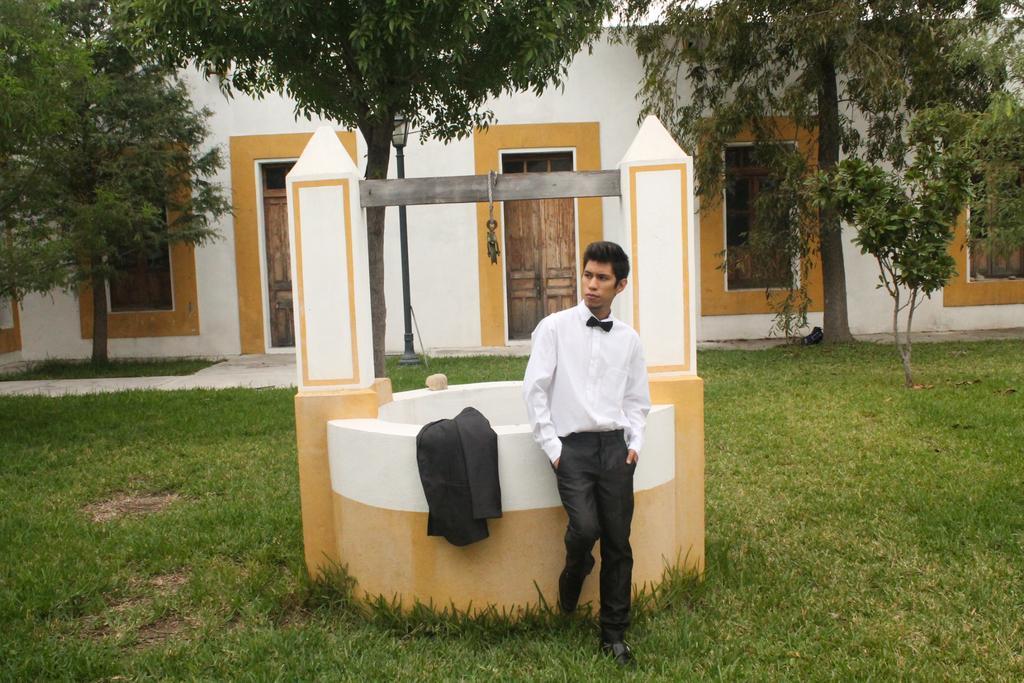Can you describe this image briefly? In this picture we can see a man is standing on the grass, beside to him we can find a jacket, in the background we can see few trees, light, metal rod and a building. 